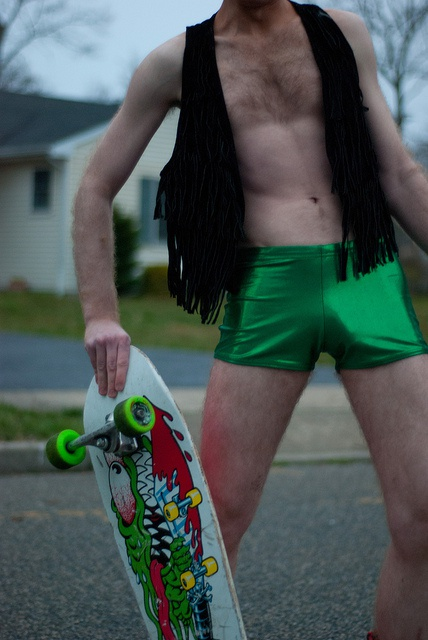Describe the objects in this image and their specific colors. I can see people in lightblue, gray, black, and darkgreen tones and skateboard in lightblue, black, gray, and darkgreen tones in this image. 